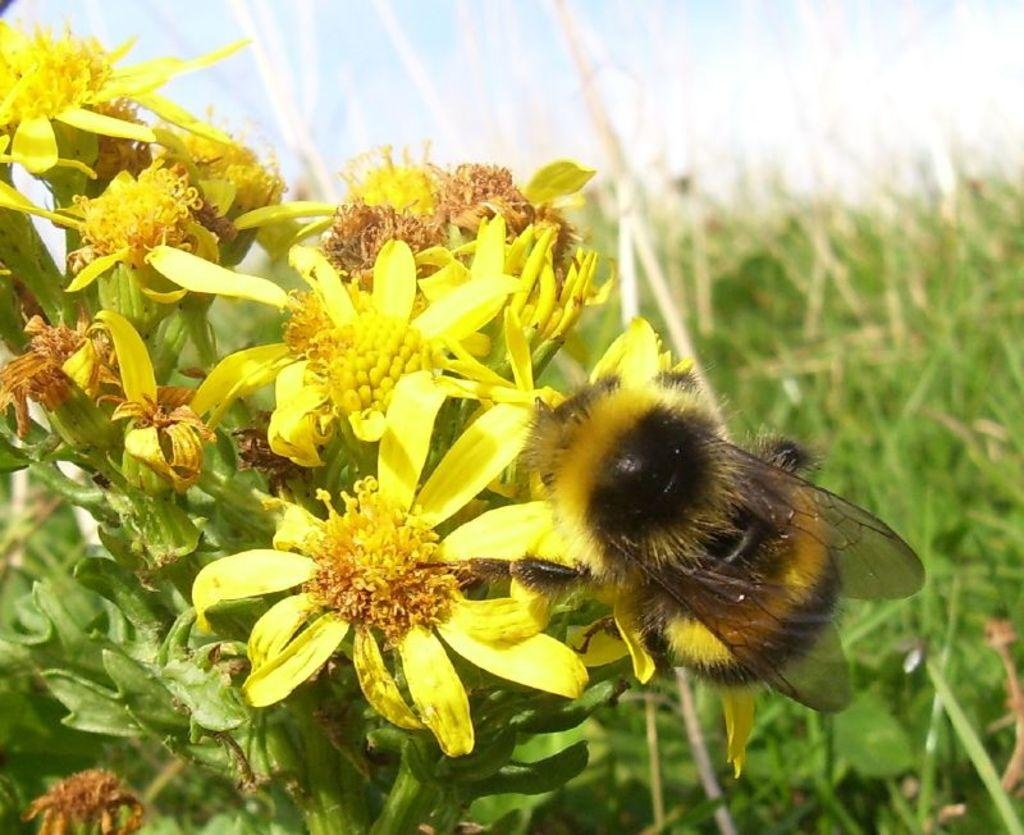What type of insect can be seen in the image? There is a honey bee in the image. What is the honey bee interacting with in the image? The honey bee is interacting with flowers in the image. What type of vegetation is present in the image? There is grass and plants in the image. Where is the market located in the image? There is no market present in the image. How many rings can be seen on the honey bee's legs in the image? Honey bees do not have rings on their legs, and there are no rings visible in the image. 